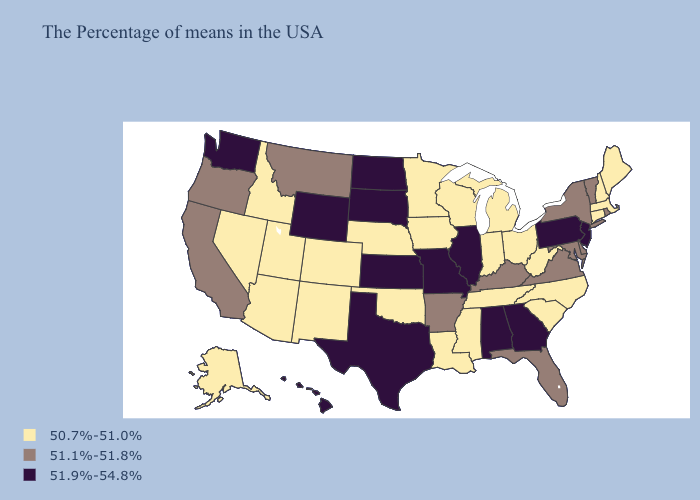Name the states that have a value in the range 51.9%-54.8%?
Write a very short answer. New Jersey, Pennsylvania, Georgia, Alabama, Illinois, Missouri, Kansas, Texas, South Dakota, North Dakota, Wyoming, Washington, Hawaii. Does the first symbol in the legend represent the smallest category?
Quick response, please. Yes. Among the states that border Florida , which have the lowest value?
Concise answer only. Georgia, Alabama. What is the lowest value in the South?
Be succinct. 50.7%-51.0%. What is the value of Alaska?
Answer briefly. 50.7%-51.0%. Name the states that have a value in the range 51.9%-54.8%?
Be succinct. New Jersey, Pennsylvania, Georgia, Alabama, Illinois, Missouri, Kansas, Texas, South Dakota, North Dakota, Wyoming, Washington, Hawaii. Which states have the lowest value in the West?
Give a very brief answer. Colorado, New Mexico, Utah, Arizona, Idaho, Nevada, Alaska. Name the states that have a value in the range 51.9%-54.8%?
Give a very brief answer. New Jersey, Pennsylvania, Georgia, Alabama, Illinois, Missouri, Kansas, Texas, South Dakota, North Dakota, Wyoming, Washington, Hawaii. Does Iowa have the lowest value in the MidWest?
Concise answer only. Yes. Among the states that border Massachusetts , does New York have the lowest value?
Keep it brief. No. Which states hav the highest value in the South?
Be succinct. Georgia, Alabama, Texas. Does Mississippi have the same value as Wyoming?
Answer briefly. No. What is the value of North Carolina?
Concise answer only. 50.7%-51.0%. What is the lowest value in the South?
Quick response, please. 50.7%-51.0%. Does Oklahoma have the same value as Arizona?
Concise answer only. Yes. 